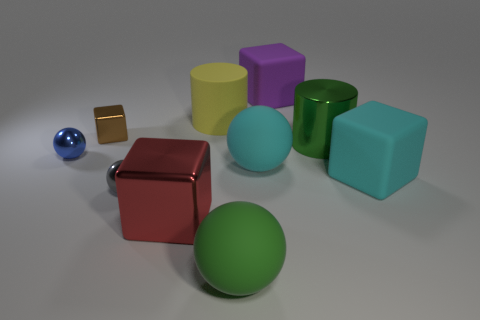What is the size of the rubber sphere that is the same color as the metallic cylinder?
Keep it short and to the point. Large. Does the small brown block have the same material as the big green object behind the large red object?
Keep it short and to the point. Yes. What material is the tiny cube?
Your answer should be very brief. Metal. What number of other objects are there of the same material as the green sphere?
Offer a terse response. 4. There is a big matte object that is behind the big cyan sphere and left of the purple rubber cube; what is its shape?
Your response must be concise. Cylinder. The other cube that is the same material as the large red cube is what color?
Provide a short and direct response. Brown. Are there an equal number of big cylinders in front of the cyan rubber ball and red metallic cylinders?
Give a very brief answer. Yes. What is the shape of the yellow matte object that is the same size as the red metallic cube?
Provide a short and direct response. Cylinder. How many other objects are the same shape as the large purple rubber object?
Your answer should be compact. 3. Do the green ball and the gray ball in front of the small blue metallic object have the same size?
Provide a succinct answer. No. 